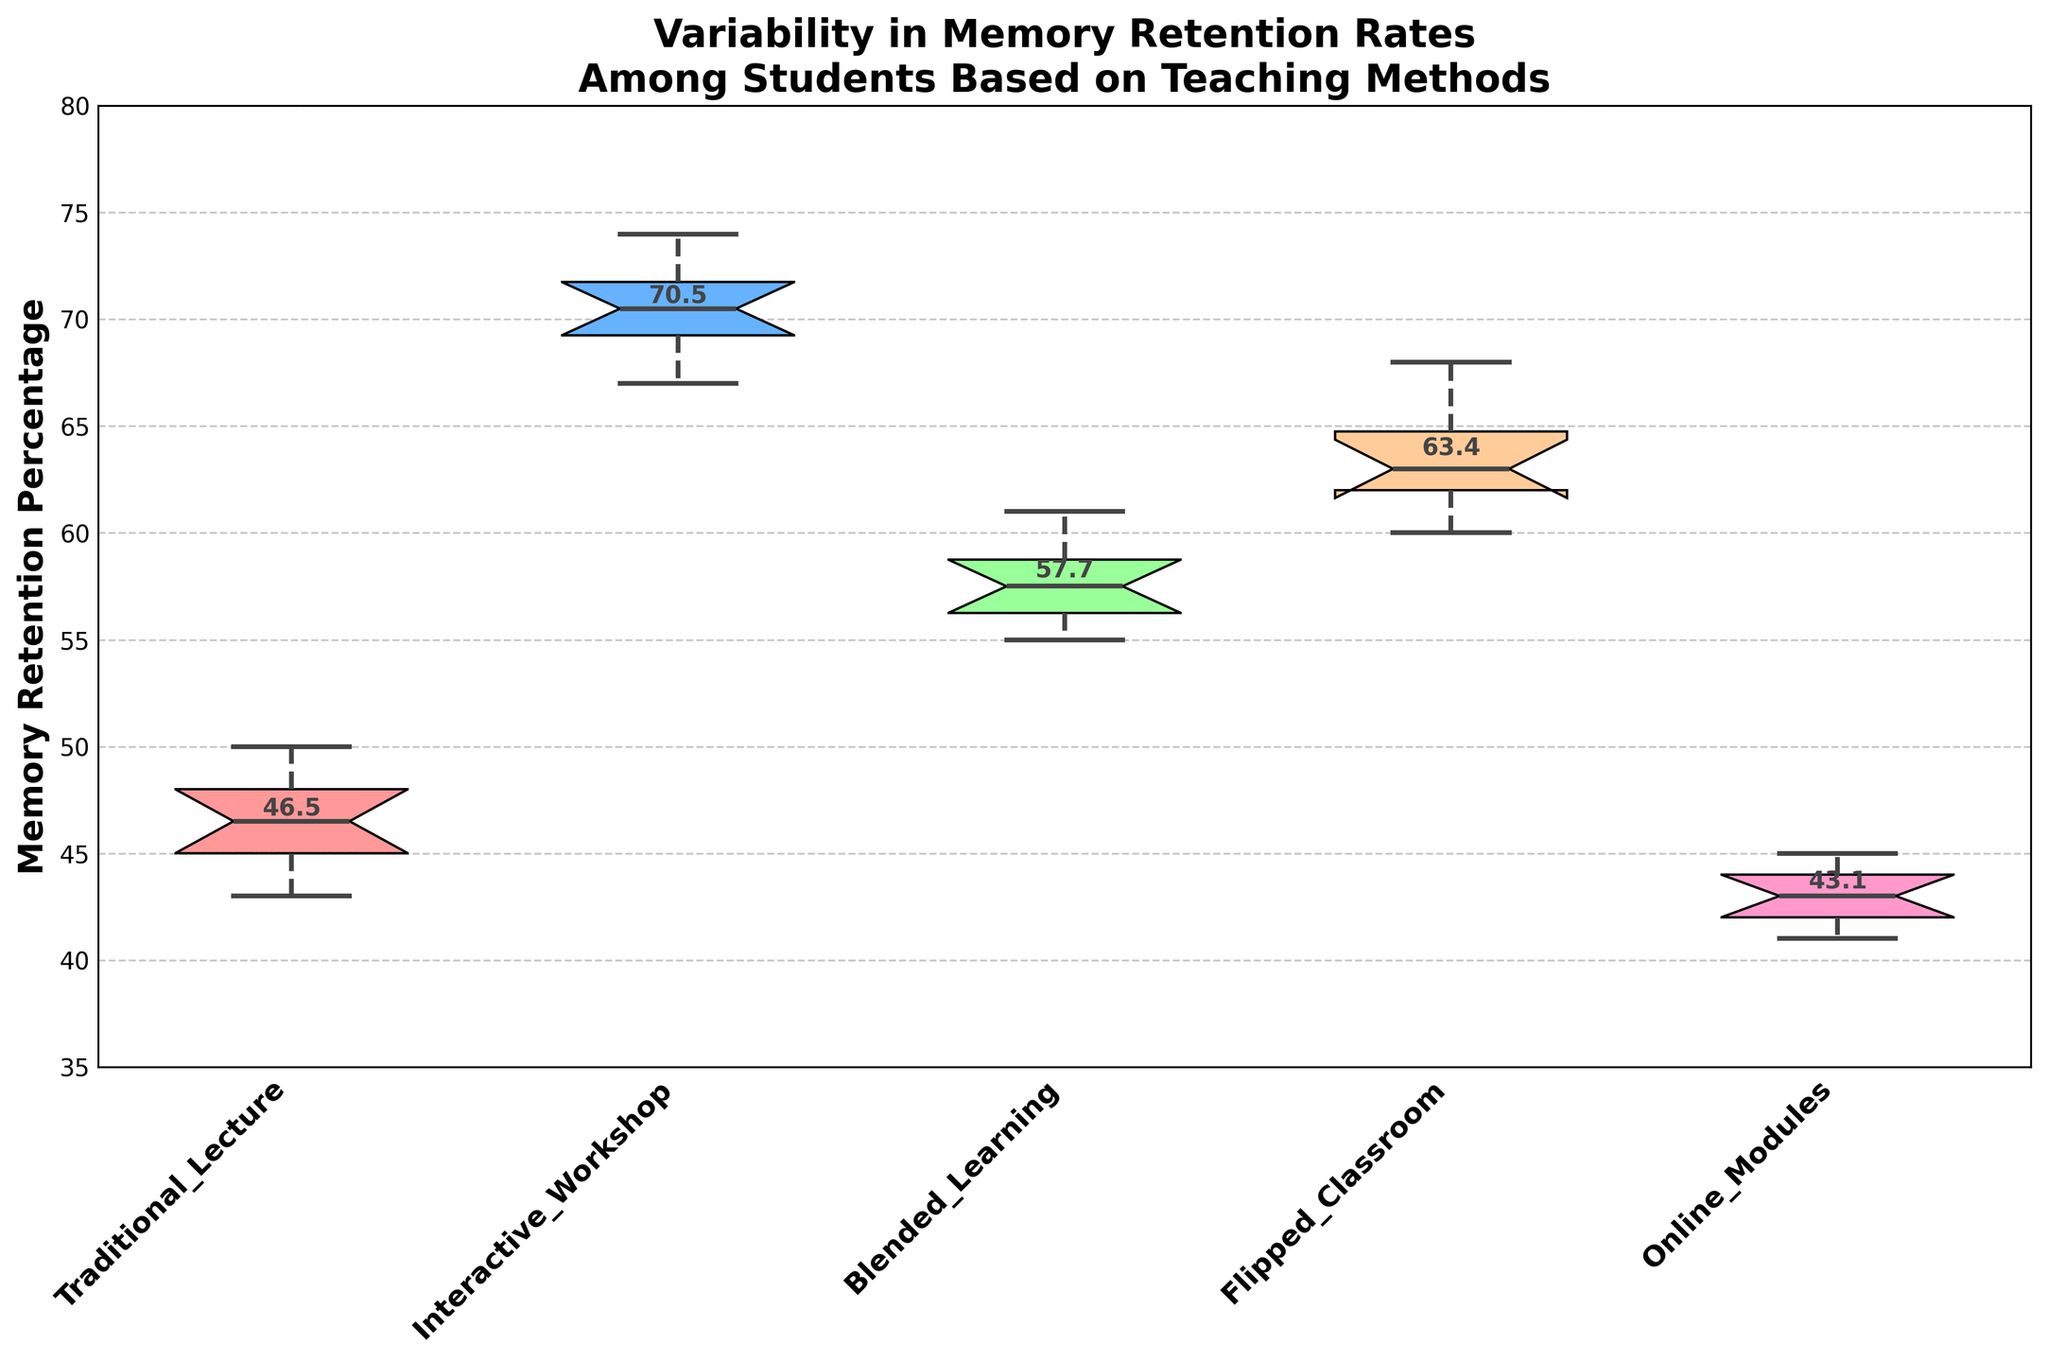What is the notched box plot displaying? The notched box plot displays the variability in memory retention rates among students based on different teaching methods.
Answer: Variability in memory retention rates based on teaching methods Which teaching method has the highest median memory retention rate? The notched box plot shows the median as the center line within each box, and it is compared across all teaching methods. The median for "Interactive Workshop" is the highest.
Answer: Interactive Workshop What does the notch in each box plot represent? The notch in a box plot represents the confidence interval around the median. If the notches of two box plots do not overlap, it is a strong indication that the medians are significantly different.
Answer: Confidence interval around the median Which teaching method shows the greatest variability in memory retention rates? The variability is shown by the length of the whiskers and spread of the data within the box. "Flipped Classroom" has the largest spread, indicating the greatest variability.
Answer: Flipped Classroom Compare the medians of Traditional Lecture and Online Modules. Which one is higher? Observing the center lines of the two notched box plots, the median of Traditional Lecture is higher than that of Online Modules.
Answer: Traditional Lecture How do the memory retention rates for the Blended Learning method compare to the Flipped Classroom method? By looking at the boxes and whiskers, Blended Learning shows a lower median and a smaller spread compared to Flipped Classroom, indicating that Flipped Classroom has both higher and more variable retention rates.
Answer: Flipped Classroom higher and more variable Is there a method with significantly different medians compared to others? Checking if the notches of any two box plots do not overlap gives an indication of significant differences. "Interactive Workshop" has a non-overlapping notch with other methods, suggesting its median is significantly different.
Answer: Interactive Workshop What can be inferred if the notches of two box plots overlap? If the notches of two box plots overlap, it suggests that the medians are not significantly different.
Answer: Medians not significantly different What is the interquartile range (IQR) for Blended Learning? The IQR is the range between the first quartile (Q1) and the third quartile (Q3). Looking at the box for Blended Learning, Q1 is approximately 56, and Q3 is approximately 59, so IQR = Q3 - Q1.
Answer: 3 Are there any outliers in the data? Outliers in a box plot are typically marked by individual points beyond the whiskers. Observing the figure, no separate points beyond the whiskers are visible, indicating no outliers.
Answer: No 